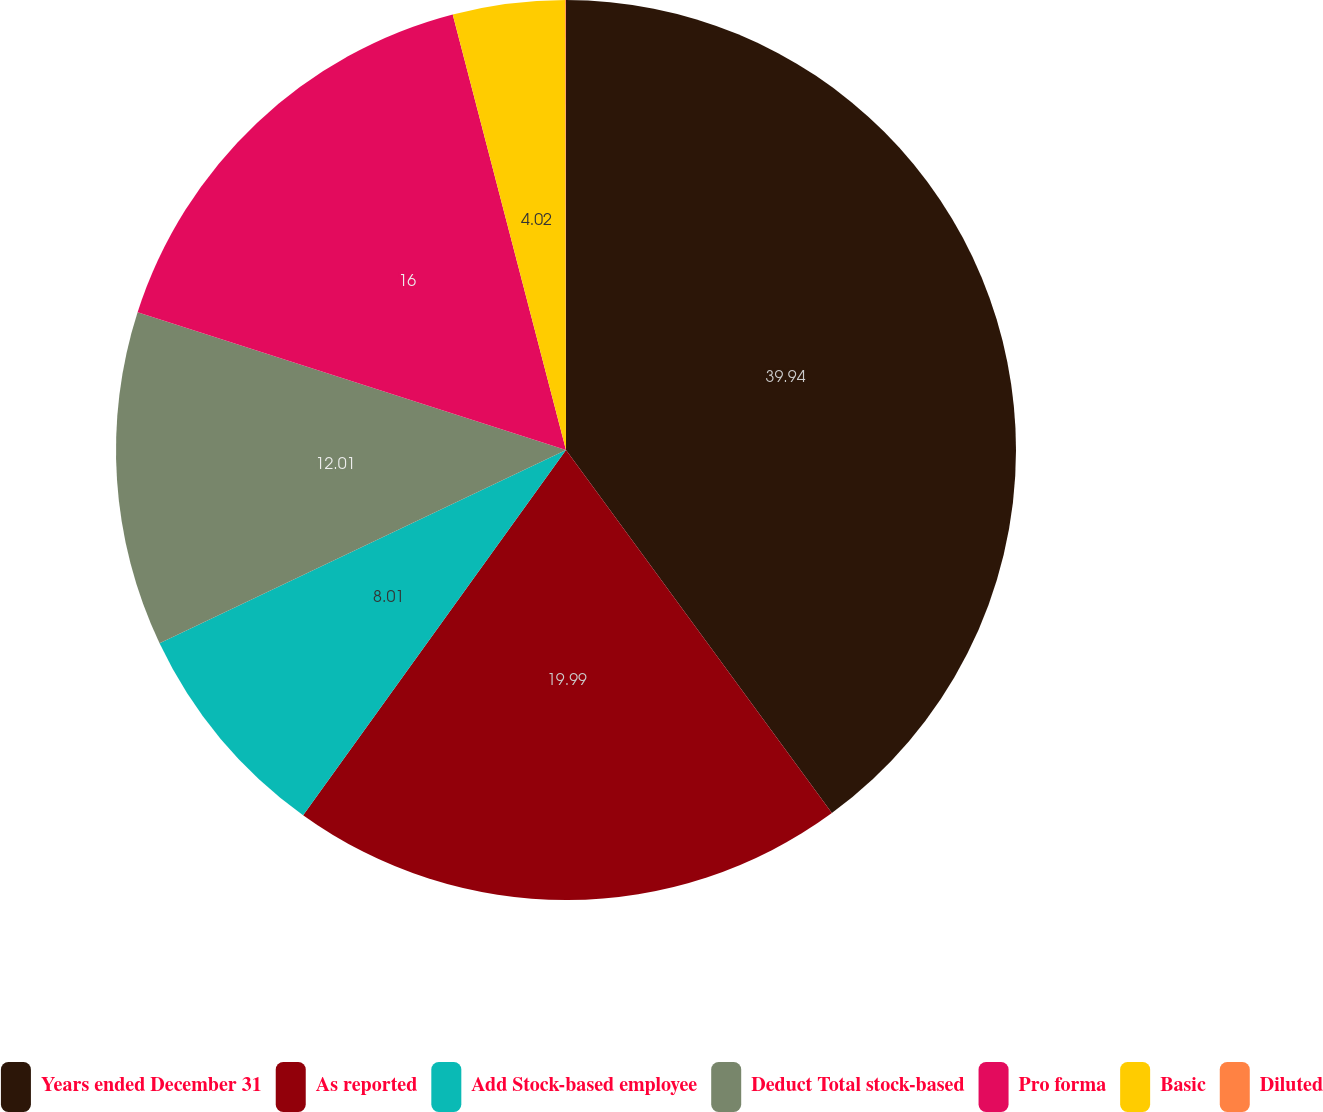Convert chart. <chart><loc_0><loc_0><loc_500><loc_500><pie_chart><fcel>Years ended December 31<fcel>As reported<fcel>Add Stock-based employee<fcel>Deduct Total stock-based<fcel>Pro forma<fcel>Basic<fcel>Diluted<nl><fcel>39.94%<fcel>19.99%<fcel>8.01%<fcel>12.01%<fcel>16.0%<fcel>4.02%<fcel>0.03%<nl></chart> 